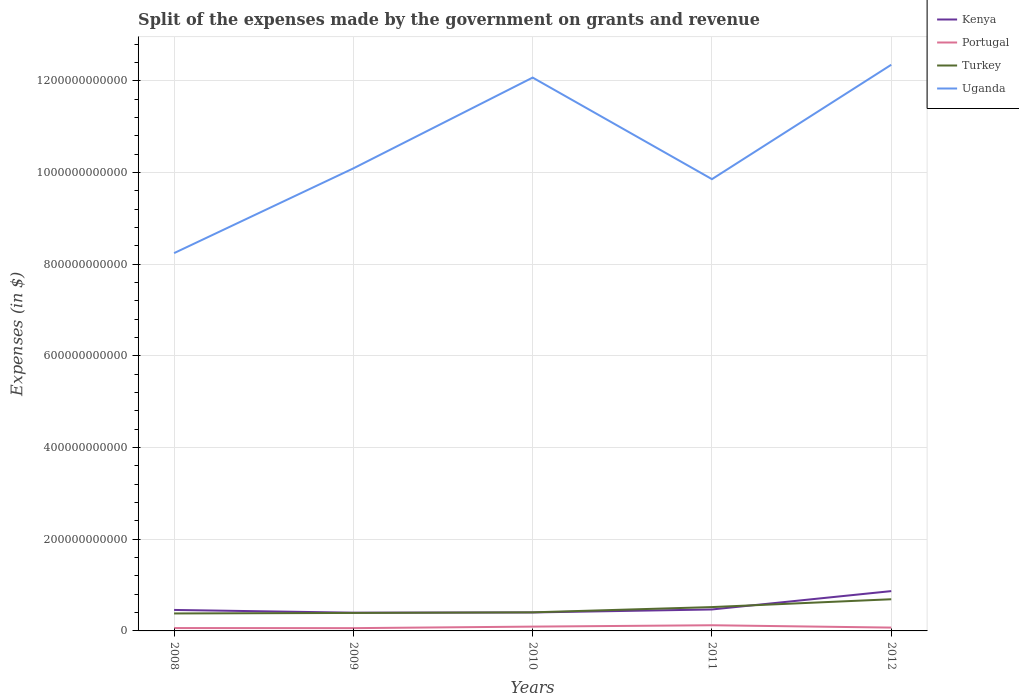Does the line corresponding to Turkey intersect with the line corresponding to Portugal?
Offer a very short reply. No. Is the number of lines equal to the number of legend labels?
Ensure brevity in your answer.  Yes. Across all years, what is the maximum expenses made by the government on grants and revenue in Portugal?
Offer a terse response. 6.08e+09. What is the total expenses made by the government on grants and revenue in Uganda in the graph?
Your response must be concise. -2.80e+1. What is the difference between the highest and the second highest expenses made by the government on grants and revenue in Kenya?
Give a very brief answer. 4.71e+1. What is the difference between two consecutive major ticks on the Y-axis?
Provide a succinct answer. 2.00e+11. Does the graph contain grids?
Provide a short and direct response. Yes. How many legend labels are there?
Give a very brief answer. 4. How are the legend labels stacked?
Provide a succinct answer. Vertical. What is the title of the graph?
Your response must be concise. Split of the expenses made by the government on grants and revenue. What is the label or title of the X-axis?
Your response must be concise. Years. What is the label or title of the Y-axis?
Provide a short and direct response. Expenses (in $). What is the Expenses (in $) in Kenya in 2008?
Give a very brief answer. 4.58e+1. What is the Expenses (in $) of Portugal in 2008?
Keep it short and to the point. 6.28e+09. What is the Expenses (in $) in Turkey in 2008?
Your answer should be compact. 3.81e+1. What is the Expenses (in $) of Uganda in 2008?
Provide a short and direct response. 8.24e+11. What is the Expenses (in $) of Kenya in 2009?
Provide a short and direct response. 3.98e+1. What is the Expenses (in $) of Portugal in 2009?
Your answer should be compact. 6.08e+09. What is the Expenses (in $) in Turkey in 2009?
Make the answer very short. 3.92e+1. What is the Expenses (in $) of Uganda in 2009?
Provide a short and direct response. 1.01e+12. What is the Expenses (in $) in Kenya in 2010?
Ensure brevity in your answer.  4.03e+1. What is the Expenses (in $) of Portugal in 2010?
Your answer should be compact. 9.40e+09. What is the Expenses (in $) of Turkey in 2010?
Provide a short and direct response. 4.05e+1. What is the Expenses (in $) in Uganda in 2010?
Offer a terse response. 1.21e+12. What is the Expenses (in $) of Kenya in 2011?
Offer a terse response. 4.68e+1. What is the Expenses (in $) of Portugal in 2011?
Provide a short and direct response. 1.24e+1. What is the Expenses (in $) in Turkey in 2011?
Your answer should be compact. 5.20e+1. What is the Expenses (in $) in Uganda in 2011?
Offer a terse response. 9.86e+11. What is the Expenses (in $) of Kenya in 2012?
Offer a terse response. 8.69e+1. What is the Expenses (in $) in Portugal in 2012?
Give a very brief answer. 7.26e+09. What is the Expenses (in $) of Turkey in 2012?
Offer a terse response. 6.91e+1. What is the Expenses (in $) in Uganda in 2012?
Keep it short and to the point. 1.24e+12. Across all years, what is the maximum Expenses (in $) of Kenya?
Keep it short and to the point. 8.69e+1. Across all years, what is the maximum Expenses (in $) in Portugal?
Provide a short and direct response. 1.24e+1. Across all years, what is the maximum Expenses (in $) in Turkey?
Provide a short and direct response. 6.91e+1. Across all years, what is the maximum Expenses (in $) in Uganda?
Provide a succinct answer. 1.24e+12. Across all years, what is the minimum Expenses (in $) in Kenya?
Provide a succinct answer. 3.98e+1. Across all years, what is the minimum Expenses (in $) in Portugal?
Your answer should be compact. 6.08e+09. Across all years, what is the minimum Expenses (in $) in Turkey?
Offer a terse response. 3.81e+1. Across all years, what is the minimum Expenses (in $) of Uganda?
Keep it short and to the point. 8.24e+11. What is the total Expenses (in $) in Kenya in the graph?
Offer a very short reply. 2.60e+11. What is the total Expenses (in $) in Portugal in the graph?
Provide a succinct answer. 4.14e+1. What is the total Expenses (in $) of Turkey in the graph?
Provide a short and direct response. 2.39e+11. What is the total Expenses (in $) in Uganda in the graph?
Your answer should be compact. 5.26e+12. What is the difference between the Expenses (in $) in Kenya in 2008 and that in 2009?
Your answer should be compact. 6.02e+09. What is the difference between the Expenses (in $) in Portugal in 2008 and that in 2009?
Your answer should be very brief. 2.08e+08. What is the difference between the Expenses (in $) in Turkey in 2008 and that in 2009?
Your answer should be compact. -1.11e+09. What is the difference between the Expenses (in $) in Uganda in 2008 and that in 2009?
Make the answer very short. -1.85e+11. What is the difference between the Expenses (in $) in Kenya in 2008 and that in 2010?
Offer a terse response. 5.50e+09. What is the difference between the Expenses (in $) of Portugal in 2008 and that in 2010?
Your answer should be very brief. -3.12e+09. What is the difference between the Expenses (in $) of Turkey in 2008 and that in 2010?
Offer a terse response. -2.41e+09. What is the difference between the Expenses (in $) of Uganda in 2008 and that in 2010?
Your answer should be very brief. -3.83e+11. What is the difference between the Expenses (in $) in Kenya in 2008 and that in 2011?
Make the answer very short. -1.02e+09. What is the difference between the Expenses (in $) in Portugal in 2008 and that in 2011?
Your answer should be compact. -6.10e+09. What is the difference between the Expenses (in $) in Turkey in 2008 and that in 2011?
Make the answer very short. -1.39e+1. What is the difference between the Expenses (in $) of Uganda in 2008 and that in 2011?
Make the answer very short. -1.61e+11. What is the difference between the Expenses (in $) in Kenya in 2008 and that in 2012?
Offer a very short reply. -4.11e+1. What is the difference between the Expenses (in $) of Portugal in 2008 and that in 2012?
Offer a terse response. -9.75e+08. What is the difference between the Expenses (in $) of Turkey in 2008 and that in 2012?
Your answer should be compact. -3.10e+1. What is the difference between the Expenses (in $) in Uganda in 2008 and that in 2012?
Ensure brevity in your answer.  -4.11e+11. What is the difference between the Expenses (in $) in Kenya in 2009 and that in 2010?
Make the answer very short. -5.18e+08. What is the difference between the Expenses (in $) in Portugal in 2009 and that in 2010?
Offer a very short reply. -3.33e+09. What is the difference between the Expenses (in $) of Turkey in 2009 and that in 2010?
Your answer should be very brief. -1.29e+09. What is the difference between the Expenses (in $) in Uganda in 2009 and that in 2010?
Your response must be concise. -1.98e+11. What is the difference between the Expenses (in $) of Kenya in 2009 and that in 2011?
Your answer should be compact. -7.04e+09. What is the difference between the Expenses (in $) in Portugal in 2009 and that in 2011?
Give a very brief answer. -6.31e+09. What is the difference between the Expenses (in $) in Turkey in 2009 and that in 2011?
Keep it short and to the point. -1.28e+1. What is the difference between the Expenses (in $) in Uganda in 2009 and that in 2011?
Your response must be concise. 2.35e+1. What is the difference between the Expenses (in $) in Kenya in 2009 and that in 2012?
Give a very brief answer. -4.71e+1. What is the difference between the Expenses (in $) of Portugal in 2009 and that in 2012?
Your response must be concise. -1.18e+09. What is the difference between the Expenses (in $) of Turkey in 2009 and that in 2012?
Give a very brief answer. -2.99e+1. What is the difference between the Expenses (in $) in Uganda in 2009 and that in 2012?
Provide a succinct answer. -2.26e+11. What is the difference between the Expenses (in $) of Kenya in 2010 and that in 2011?
Offer a very short reply. -6.52e+09. What is the difference between the Expenses (in $) of Portugal in 2010 and that in 2011?
Your answer should be compact. -2.98e+09. What is the difference between the Expenses (in $) of Turkey in 2010 and that in 2011?
Provide a short and direct response. -1.15e+1. What is the difference between the Expenses (in $) in Uganda in 2010 and that in 2011?
Provide a succinct answer. 2.22e+11. What is the difference between the Expenses (in $) of Kenya in 2010 and that in 2012?
Your answer should be very brief. -4.66e+1. What is the difference between the Expenses (in $) of Portugal in 2010 and that in 2012?
Make the answer very short. 2.14e+09. What is the difference between the Expenses (in $) of Turkey in 2010 and that in 2012?
Give a very brief answer. -2.86e+1. What is the difference between the Expenses (in $) of Uganda in 2010 and that in 2012?
Give a very brief answer. -2.80e+1. What is the difference between the Expenses (in $) of Kenya in 2011 and that in 2012?
Provide a short and direct response. -4.00e+1. What is the difference between the Expenses (in $) of Portugal in 2011 and that in 2012?
Your response must be concise. 5.13e+09. What is the difference between the Expenses (in $) of Turkey in 2011 and that in 2012?
Make the answer very short. -1.71e+1. What is the difference between the Expenses (in $) in Uganda in 2011 and that in 2012?
Keep it short and to the point. -2.50e+11. What is the difference between the Expenses (in $) of Kenya in 2008 and the Expenses (in $) of Portugal in 2009?
Offer a very short reply. 3.97e+1. What is the difference between the Expenses (in $) of Kenya in 2008 and the Expenses (in $) of Turkey in 2009?
Offer a terse response. 6.56e+09. What is the difference between the Expenses (in $) in Kenya in 2008 and the Expenses (in $) in Uganda in 2009?
Keep it short and to the point. -9.63e+11. What is the difference between the Expenses (in $) in Portugal in 2008 and the Expenses (in $) in Turkey in 2009?
Your answer should be very brief. -3.30e+1. What is the difference between the Expenses (in $) in Portugal in 2008 and the Expenses (in $) in Uganda in 2009?
Make the answer very short. -1.00e+12. What is the difference between the Expenses (in $) of Turkey in 2008 and the Expenses (in $) of Uganda in 2009?
Provide a succinct answer. -9.71e+11. What is the difference between the Expenses (in $) in Kenya in 2008 and the Expenses (in $) in Portugal in 2010?
Ensure brevity in your answer.  3.64e+1. What is the difference between the Expenses (in $) of Kenya in 2008 and the Expenses (in $) of Turkey in 2010?
Ensure brevity in your answer.  5.26e+09. What is the difference between the Expenses (in $) in Kenya in 2008 and the Expenses (in $) in Uganda in 2010?
Keep it short and to the point. -1.16e+12. What is the difference between the Expenses (in $) of Portugal in 2008 and the Expenses (in $) of Turkey in 2010?
Offer a very short reply. -3.42e+1. What is the difference between the Expenses (in $) in Portugal in 2008 and the Expenses (in $) in Uganda in 2010?
Provide a succinct answer. -1.20e+12. What is the difference between the Expenses (in $) in Turkey in 2008 and the Expenses (in $) in Uganda in 2010?
Make the answer very short. -1.17e+12. What is the difference between the Expenses (in $) of Kenya in 2008 and the Expenses (in $) of Portugal in 2011?
Offer a terse response. 3.34e+1. What is the difference between the Expenses (in $) in Kenya in 2008 and the Expenses (in $) in Turkey in 2011?
Offer a terse response. -6.22e+09. What is the difference between the Expenses (in $) in Kenya in 2008 and the Expenses (in $) in Uganda in 2011?
Offer a terse response. -9.40e+11. What is the difference between the Expenses (in $) of Portugal in 2008 and the Expenses (in $) of Turkey in 2011?
Ensure brevity in your answer.  -4.57e+1. What is the difference between the Expenses (in $) in Portugal in 2008 and the Expenses (in $) in Uganda in 2011?
Provide a succinct answer. -9.79e+11. What is the difference between the Expenses (in $) of Turkey in 2008 and the Expenses (in $) of Uganda in 2011?
Keep it short and to the point. -9.47e+11. What is the difference between the Expenses (in $) in Kenya in 2008 and the Expenses (in $) in Portugal in 2012?
Provide a succinct answer. 3.85e+1. What is the difference between the Expenses (in $) in Kenya in 2008 and the Expenses (in $) in Turkey in 2012?
Make the answer very short. -2.33e+1. What is the difference between the Expenses (in $) in Kenya in 2008 and the Expenses (in $) in Uganda in 2012?
Your answer should be very brief. -1.19e+12. What is the difference between the Expenses (in $) in Portugal in 2008 and the Expenses (in $) in Turkey in 2012?
Offer a very short reply. -6.28e+1. What is the difference between the Expenses (in $) in Portugal in 2008 and the Expenses (in $) in Uganda in 2012?
Make the answer very short. -1.23e+12. What is the difference between the Expenses (in $) of Turkey in 2008 and the Expenses (in $) of Uganda in 2012?
Keep it short and to the point. -1.20e+12. What is the difference between the Expenses (in $) in Kenya in 2009 and the Expenses (in $) in Portugal in 2010?
Make the answer very short. 3.04e+1. What is the difference between the Expenses (in $) in Kenya in 2009 and the Expenses (in $) in Turkey in 2010?
Your answer should be very brief. -7.58e+08. What is the difference between the Expenses (in $) of Kenya in 2009 and the Expenses (in $) of Uganda in 2010?
Your answer should be very brief. -1.17e+12. What is the difference between the Expenses (in $) in Portugal in 2009 and the Expenses (in $) in Turkey in 2010?
Your response must be concise. -3.45e+1. What is the difference between the Expenses (in $) of Portugal in 2009 and the Expenses (in $) of Uganda in 2010?
Provide a succinct answer. -1.20e+12. What is the difference between the Expenses (in $) of Turkey in 2009 and the Expenses (in $) of Uganda in 2010?
Ensure brevity in your answer.  -1.17e+12. What is the difference between the Expenses (in $) of Kenya in 2009 and the Expenses (in $) of Portugal in 2011?
Your answer should be very brief. 2.74e+1. What is the difference between the Expenses (in $) in Kenya in 2009 and the Expenses (in $) in Turkey in 2011?
Give a very brief answer. -1.22e+1. What is the difference between the Expenses (in $) of Kenya in 2009 and the Expenses (in $) of Uganda in 2011?
Make the answer very short. -9.46e+11. What is the difference between the Expenses (in $) of Portugal in 2009 and the Expenses (in $) of Turkey in 2011?
Your response must be concise. -4.59e+1. What is the difference between the Expenses (in $) in Portugal in 2009 and the Expenses (in $) in Uganda in 2011?
Offer a very short reply. -9.79e+11. What is the difference between the Expenses (in $) of Turkey in 2009 and the Expenses (in $) of Uganda in 2011?
Provide a succinct answer. -9.46e+11. What is the difference between the Expenses (in $) in Kenya in 2009 and the Expenses (in $) in Portugal in 2012?
Make the answer very short. 3.25e+1. What is the difference between the Expenses (in $) of Kenya in 2009 and the Expenses (in $) of Turkey in 2012?
Your answer should be compact. -2.93e+1. What is the difference between the Expenses (in $) of Kenya in 2009 and the Expenses (in $) of Uganda in 2012?
Provide a short and direct response. -1.20e+12. What is the difference between the Expenses (in $) in Portugal in 2009 and the Expenses (in $) in Turkey in 2012?
Provide a succinct answer. -6.30e+1. What is the difference between the Expenses (in $) in Portugal in 2009 and the Expenses (in $) in Uganda in 2012?
Provide a short and direct response. -1.23e+12. What is the difference between the Expenses (in $) in Turkey in 2009 and the Expenses (in $) in Uganda in 2012?
Offer a terse response. -1.20e+12. What is the difference between the Expenses (in $) in Kenya in 2010 and the Expenses (in $) in Portugal in 2011?
Your answer should be very brief. 2.79e+1. What is the difference between the Expenses (in $) in Kenya in 2010 and the Expenses (in $) in Turkey in 2011?
Make the answer very short. -1.17e+1. What is the difference between the Expenses (in $) in Kenya in 2010 and the Expenses (in $) in Uganda in 2011?
Make the answer very short. -9.45e+11. What is the difference between the Expenses (in $) in Portugal in 2010 and the Expenses (in $) in Turkey in 2011?
Ensure brevity in your answer.  -4.26e+1. What is the difference between the Expenses (in $) in Portugal in 2010 and the Expenses (in $) in Uganda in 2011?
Provide a short and direct response. -9.76e+11. What is the difference between the Expenses (in $) in Turkey in 2010 and the Expenses (in $) in Uganda in 2011?
Provide a short and direct response. -9.45e+11. What is the difference between the Expenses (in $) in Kenya in 2010 and the Expenses (in $) in Portugal in 2012?
Ensure brevity in your answer.  3.30e+1. What is the difference between the Expenses (in $) of Kenya in 2010 and the Expenses (in $) of Turkey in 2012?
Make the answer very short. -2.88e+1. What is the difference between the Expenses (in $) in Kenya in 2010 and the Expenses (in $) in Uganda in 2012?
Make the answer very short. -1.19e+12. What is the difference between the Expenses (in $) in Portugal in 2010 and the Expenses (in $) in Turkey in 2012?
Provide a succinct answer. -5.97e+1. What is the difference between the Expenses (in $) in Portugal in 2010 and the Expenses (in $) in Uganda in 2012?
Give a very brief answer. -1.23e+12. What is the difference between the Expenses (in $) in Turkey in 2010 and the Expenses (in $) in Uganda in 2012?
Your answer should be very brief. -1.19e+12. What is the difference between the Expenses (in $) in Kenya in 2011 and the Expenses (in $) in Portugal in 2012?
Provide a succinct answer. 3.96e+1. What is the difference between the Expenses (in $) in Kenya in 2011 and the Expenses (in $) in Turkey in 2012?
Keep it short and to the point. -2.23e+1. What is the difference between the Expenses (in $) in Kenya in 2011 and the Expenses (in $) in Uganda in 2012?
Make the answer very short. -1.19e+12. What is the difference between the Expenses (in $) of Portugal in 2011 and the Expenses (in $) of Turkey in 2012?
Your response must be concise. -5.67e+1. What is the difference between the Expenses (in $) in Portugal in 2011 and the Expenses (in $) in Uganda in 2012?
Make the answer very short. -1.22e+12. What is the difference between the Expenses (in $) in Turkey in 2011 and the Expenses (in $) in Uganda in 2012?
Provide a succinct answer. -1.18e+12. What is the average Expenses (in $) of Kenya per year?
Your response must be concise. 5.19e+1. What is the average Expenses (in $) of Portugal per year?
Provide a short and direct response. 8.28e+09. What is the average Expenses (in $) of Turkey per year?
Ensure brevity in your answer.  4.78e+1. What is the average Expenses (in $) in Uganda per year?
Offer a terse response. 1.05e+12. In the year 2008, what is the difference between the Expenses (in $) in Kenya and Expenses (in $) in Portugal?
Offer a very short reply. 3.95e+1. In the year 2008, what is the difference between the Expenses (in $) in Kenya and Expenses (in $) in Turkey?
Provide a succinct answer. 7.67e+09. In the year 2008, what is the difference between the Expenses (in $) in Kenya and Expenses (in $) in Uganda?
Provide a succinct answer. -7.78e+11. In the year 2008, what is the difference between the Expenses (in $) of Portugal and Expenses (in $) of Turkey?
Offer a very short reply. -3.18e+1. In the year 2008, what is the difference between the Expenses (in $) in Portugal and Expenses (in $) in Uganda?
Keep it short and to the point. -8.18e+11. In the year 2008, what is the difference between the Expenses (in $) in Turkey and Expenses (in $) in Uganda?
Provide a short and direct response. -7.86e+11. In the year 2009, what is the difference between the Expenses (in $) in Kenya and Expenses (in $) in Portugal?
Offer a very short reply. 3.37e+1. In the year 2009, what is the difference between the Expenses (in $) of Kenya and Expenses (in $) of Turkey?
Give a very brief answer. 5.35e+08. In the year 2009, what is the difference between the Expenses (in $) of Kenya and Expenses (in $) of Uganda?
Offer a very short reply. -9.69e+11. In the year 2009, what is the difference between the Expenses (in $) of Portugal and Expenses (in $) of Turkey?
Provide a succinct answer. -3.32e+1. In the year 2009, what is the difference between the Expenses (in $) in Portugal and Expenses (in $) in Uganda?
Offer a very short reply. -1.00e+12. In the year 2009, what is the difference between the Expenses (in $) of Turkey and Expenses (in $) of Uganda?
Give a very brief answer. -9.70e+11. In the year 2010, what is the difference between the Expenses (in $) of Kenya and Expenses (in $) of Portugal?
Provide a short and direct response. 3.09e+1. In the year 2010, what is the difference between the Expenses (in $) of Kenya and Expenses (in $) of Turkey?
Your answer should be very brief. -2.39e+08. In the year 2010, what is the difference between the Expenses (in $) in Kenya and Expenses (in $) in Uganda?
Provide a succinct answer. -1.17e+12. In the year 2010, what is the difference between the Expenses (in $) in Portugal and Expenses (in $) in Turkey?
Ensure brevity in your answer.  -3.11e+1. In the year 2010, what is the difference between the Expenses (in $) in Portugal and Expenses (in $) in Uganda?
Offer a terse response. -1.20e+12. In the year 2010, what is the difference between the Expenses (in $) in Turkey and Expenses (in $) in Uganda?
Your answer should be very brief. -1.17e+12. In the year 2011, what is the difference between the Expenses (in $) of Kenya and Expenses (in $) of Portugal?
Offer a terse response. 3.44e+1. In the year 2011, what is the difference between the Expenses (in $) of Kenya and Expenses (in $) of Turkey?
Your response must be concise. -5.20e+09. In the year 2011, what is the difference between the Expenses (in $) in Kenya and Expenses (in $) in Uganda?
Make the answer very short. -9.39e+11. In the year 2011, what is the difference between the Expenses (in $) in Portugal and Expenses (in $) in Turkey?
Provide a short and direct response. -3.96e+1. In the year 2011, what is the difference between the Expenses (in $) of Portugal and Expenses (in $) of Uganda?
Provide a succinct answer. -9.73e+11. In the year 2011, what is the difference between the Expenses (in $) of Turkey and Expenses (in $) of Uganda?
Ensure brevity in your answer.  -9.34e+11. In the year 2012, what is the difference between the Expenses (in $) of Kenya and Expenses (in $) of Portugal?
Give a very brief answer. 7.96e+1. In the year 2012, what is the difference between the Expenses (in $) in Kenya and Expenses (in $) in Turkey?
Provide a short and direct response. 1.77e+1. In the year 2012, what is the difference between the Expenses (in $) of Kenya and Expenses (in $) of Uganda?
Provide a short and direct response. -1.15e+12. In the year 2012, what is the difference between the Expenses (in $) of Portugal and Expenses (in $) of Turkey?
Give a very brief answer. -6.18e+1. In the year 2012, what is the difference between the Expenses (in $) of Portugal and Expenses (in $) of Uganda?
Offer a very short reply. -1.23e+12. In the year 2012, what is the difference between the Expenses (in $) of Turkey and Expenses (in $) of Uganda?
Your answer should be very brief. -1.17e+12. What is the ratio of the Expenses (in $) in Kenya in 2008 to that in 2009?
Provide a short and direct response. 1.15. What is the ratio of the Expenses (in $) of Portugal in 2008 to that in 2009?
Your response must be concise. 1.03. What is the ratio of the Expenses (in $) in Turkey in 2008 to that in 2009?
Your response must be concise. 0.97. What is the ratio of the Expenses (in $) in Uganda in 2008 to that in 2009?
Your answer should be very brief. 0.82. What is the ratio of the Expenses (in $) of Kenya in 2008 to that in 2010?
Your response must be concise. 1.14. What is the ratio of the Expenses (in $) of Portugal in 2008 to that in 2010?
Provide a succinct answer. 0.67. What is the ratio of the Expenses (in $) of Turkey in 2008 to that in 2010?
Ensure brevity in your answer.  0.94. What is the ratio of the Expenses (in $) of Uganda in 2008 to that in 2010?
Offer a very short reply. 0.68. What is the ratio of the Expenses (in $) in Kenya in 2008 to that in 2011?
Your answer should be compact. 0.98. What is the ratio of the Expenses (in $) in Portugal in 2008 to that in 2011?
Ensure brevity in your answer.  0.51. What is the ratio of the Expenses (in $) of Turkey in 2008 to that in 2011?
Provide a short and direct response. 0.73. What is the ratio of the Expenses (in $) of Uganda in 2008 to that in 2011?
Offer a terse response. 0.84. What is the ratio of the Expenses (in $) in Kenya in 2008 to that in 2012?
Ensure brevity in your answer.  0.53. What is the ratio of the Expenses (in $) in Portugal in 2008 to that in 2012?
Your answer should be very brief. 0.87. What is the ratio of the Expenses (in $) in Turkey in 2008 to that in 2012?
Provide a succinct answer. 0.55. What is the ratio of the Expenses (in $) in Uganda in 2008 to that in 2012?
Your response must be concise. 0.67. What is the ratio of the Expenses (in $) in Kenya in 2009 to that in 2010?
Your answer should be compact. 0.99. What is the ratio of the Expenses (in $) in Portugal in 2009 to that in 2010?
Offer a terse response. 0.65. What is the ratio of the Expenses (in $) of Turkey in 2009 to that in 2010?
Offer a very short reply. 0.97. What is the ratio of the Expenses (in $) in Uganda in 2009 to that in 2010?
Provide a succinct answer. 0.84. What is the ratio of the Expenses (in $) in Kenya in 2009 to that in 2011?
Provide a short and direct response. 0.85. What is the ratio of the Expenses (in $) of Portugal in 2009 to that in 2011?
Provide a short and direct response. 0.49. What is the ratio of the Expenses (in $) of Turkey in 2009 to that in 2011?
Your response must be concise. 0.75. What is the ratio of the Expenses (in $) of Uganda in 2009 to that in 2011?
Provide a succinct answer. 1.02. What is the ratio of the Expenses (in $) of Kenya in 2009 to that in 2012?
Ensure brevity in your answer.  0.46. What is the ratio of the Expenses (in $) of Portugal in 2009 to that in 2012?
Make the answer very short. 0.84. What is the ratio of the Expenses (in $) in Turkey in 2009 to that in 2012?
Offer a very short reply. 0.57. What is the ratio of the Expenses (in $) of Uganda in 2009 to that in 2012?
Offer a terse response. 0.82. What is the ratio of the Expenses (in $) of Kenya in 2010 to that in 2011?
Your answer should be very brief. 0.86. What is the ratio of the Expenses (in $) in Portugal in 2010 to that in 2011?
Your answer should be very brief. 0.76. What is the ratio of the Expenses (in $) in Turkey in 2010 to that in 2011?
Offer a terse response. 0.78. What is the ratio of the Expenses (in $) in Uganda in 2010 to that in 2011?
Make the answer very short. 1.22. What is the ratio of the Expenses (in $) in Kenya in 2010 to that in 2012?
Provide a short and direct response. 0.46. What is the ratio of the Expenses (in $) in Portugal in 2010 to that in 2012?
Your answer should be very brief. 1.3. What is the ratio of the Expenses (in $) in Turkey in 2010 to that in 2012?
Offer a terse response. 0.59. What is the ratio of the Expenses (in $) of Uganda in 2010 to that in 2012?
Your answer should be compact. 0.98. What is the ratio of the Expenses (in $) of Kenya in 2011 to that in 2012?
Your answer should be very brief. 0.54. What is the ratio of the Expenses (in $) of Portugal in 2011 to that in 2012?
Your response must be concise. 1.71. What is the ratio of the Expenses (in $) of Turkey in 2011 to that in 2012?
Offer a terse response. 0.75. What is the ratio of the Expenses (in $) in Uganda in 2011 to that in 2012?
Ensure brevity in your answer.  0.8. What is the difference between the highest and the second highest Expenses (in $) in Kenya?
Give a very brief answer. 4.00e+1. What is the difference between the highest and the second highest Expenses (in $) in Portugal?
Give a very brief answer. 2.98e+09. What is the difference between the highest and the second highest Expenses (in $) of Turkey?
Your response must be concise. 1.71e+1. What is the difference between the highest and the second highest Expenses (in $) in Uganda?
Your answer should be very brief. 2.80e+1. What is the difference between the highest and the lowest Expenses (in $) of Kenya?
Keep it short and to the point. 4.71e+1. What is the difference between the highest and the lowest Expenses (in $) in Portugal?
Give a very brief answer. 6.31e+09. What is the difference between the highest and the lowest Expenses (in $) of Turkey?
Offer a terse response. 3.10e+1. What is the difference between the highest and the lowest Expenses (in $) in Uganda?
Your answer should be compact. 4.11e+11. 